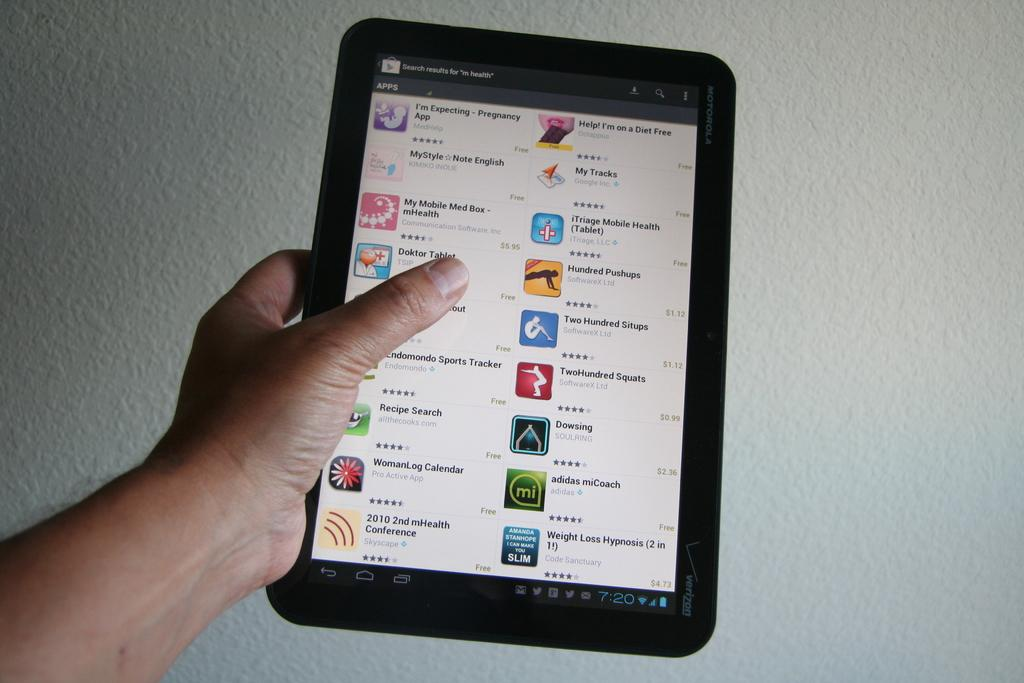What is being held by the hand in the image? The hand is holding an electronic gadget. Can you describe the electronic gadget? The electronic gadget is black in color. What can be seen in the background of the image? There is a white-colored wall in the background of the image. What direction is the flock of birds flying in the image? There are no birds present in the image, so it is not possible to determine the direction of any flock. 